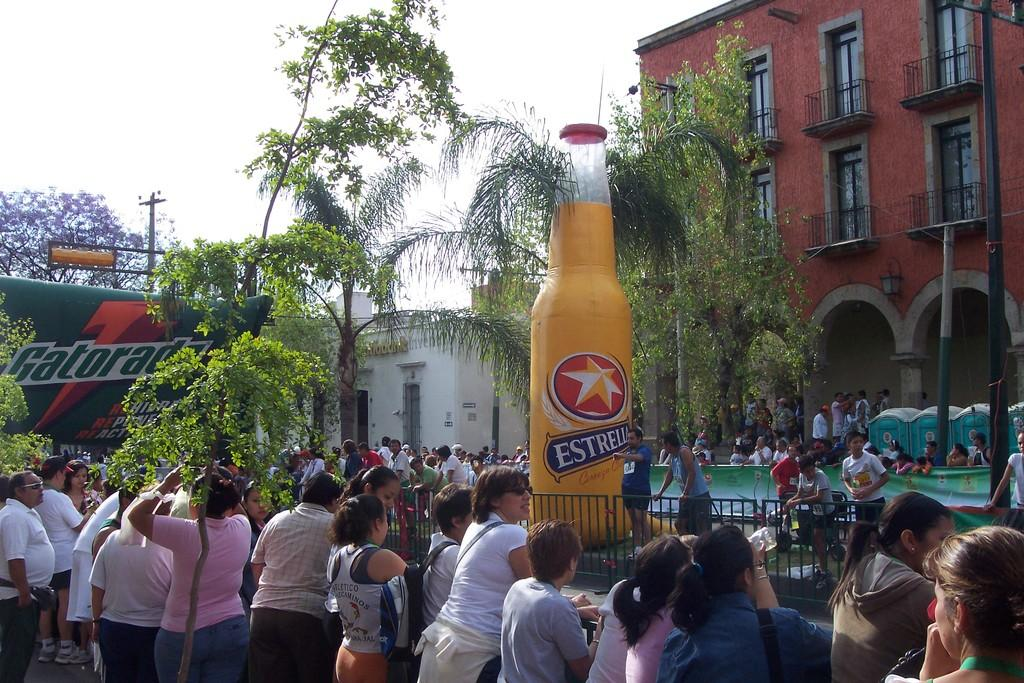<image>
Write a terse but informative summary of the picture. a large inflatable bottle with the word Estrella on it 